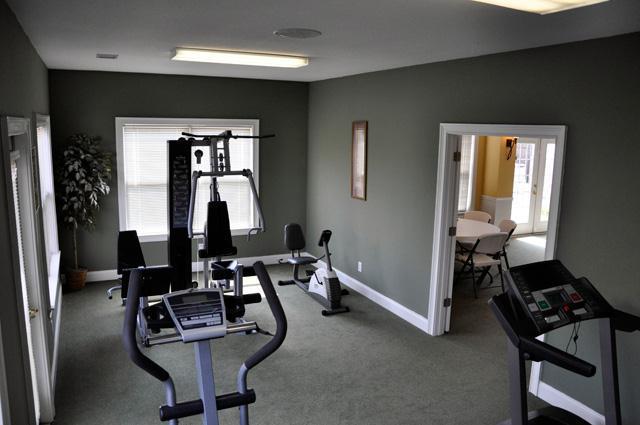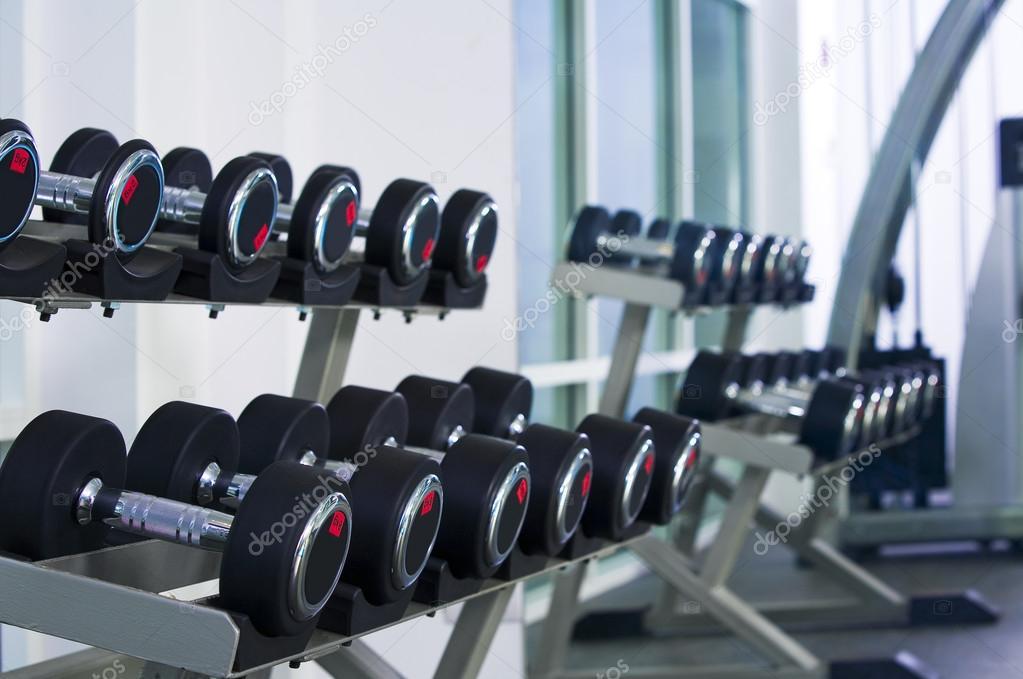The first image is the image on the left, the second image is the image on the right. For the images displayed, is the sentence "One image shows a rack with two angled rows of black dumbbells, and the other image shows a gym with workout equipment and a gray floor." factually correct? Answer yes or no. Yes. 